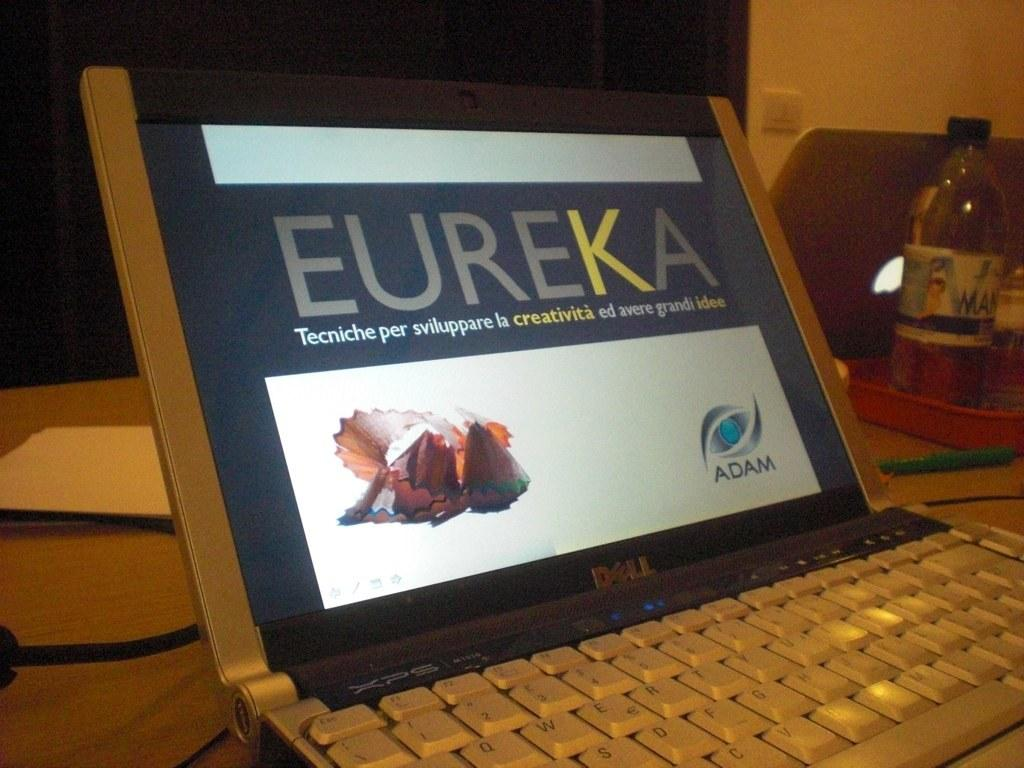<image>
Offer a succinct explanation of the picture presented. Eureka is the word written in large across this laptop screen. 